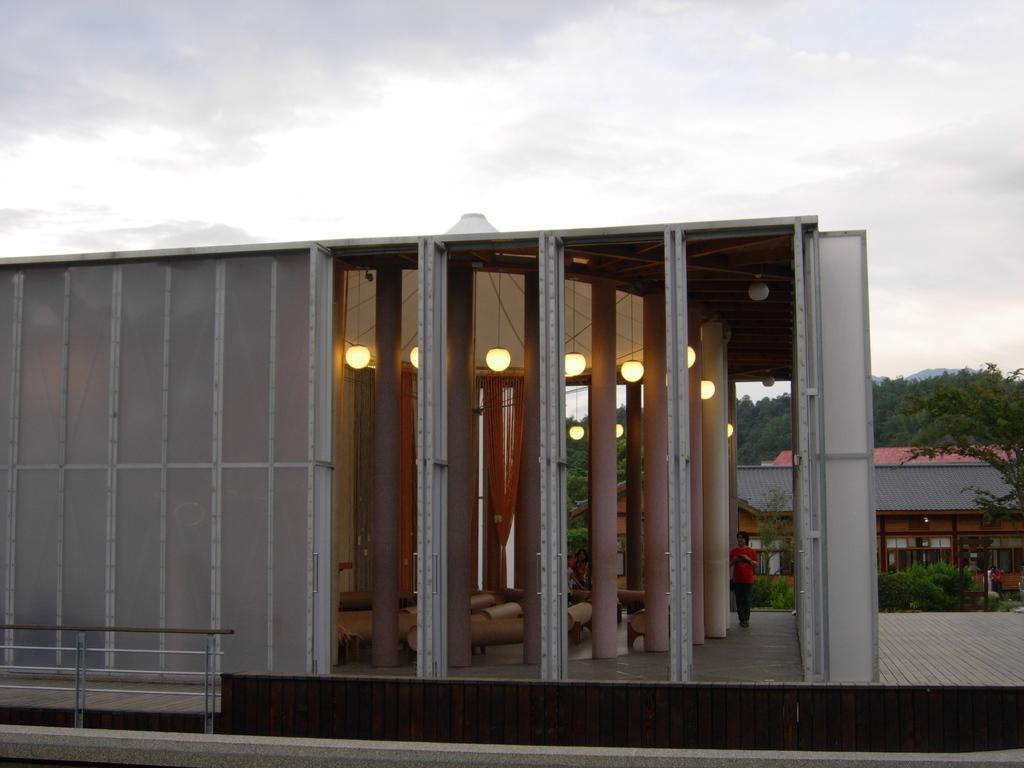What is the main subject in the center of the image? There is a building in the center of the image. What can be seen in the background of the image? There are trees in the background of the image. What is visible at the top of the image? The sky is visible at the top of the image. What can be observed in the sky? Clouds are present in the sky. What type of glove is being used for the activity in the image? There is no activity or glove present in the image; it features a building, trees, and a sky with clouds. 